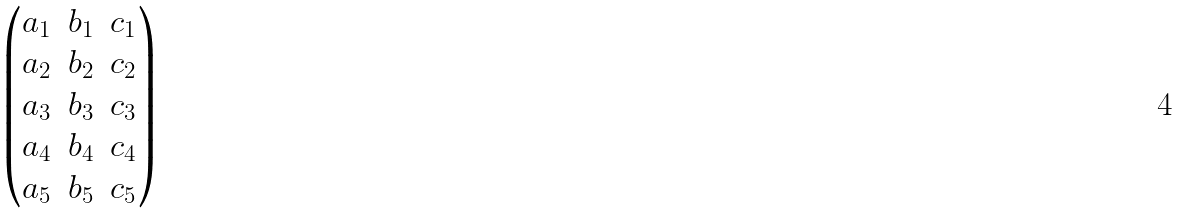Convert formula to latex. <formula><loc_0><loc_0><loc_500><loc_500>\begin{pmatrix} a _ { 1 } & b _ { 1 } & c _ { 1 } \\ a _ { 2 } & b _ { 2 } & c _ { 2 } \\ a _ { 3 } & b _ { 3 } & c _ { 3 } \\ a _ { 4 } & b _ { 4 } & c _ { 4 } \\ a _ { 5 } & b _ { 5 } & c _ { 5 } \end{pmatrix}</formula> 